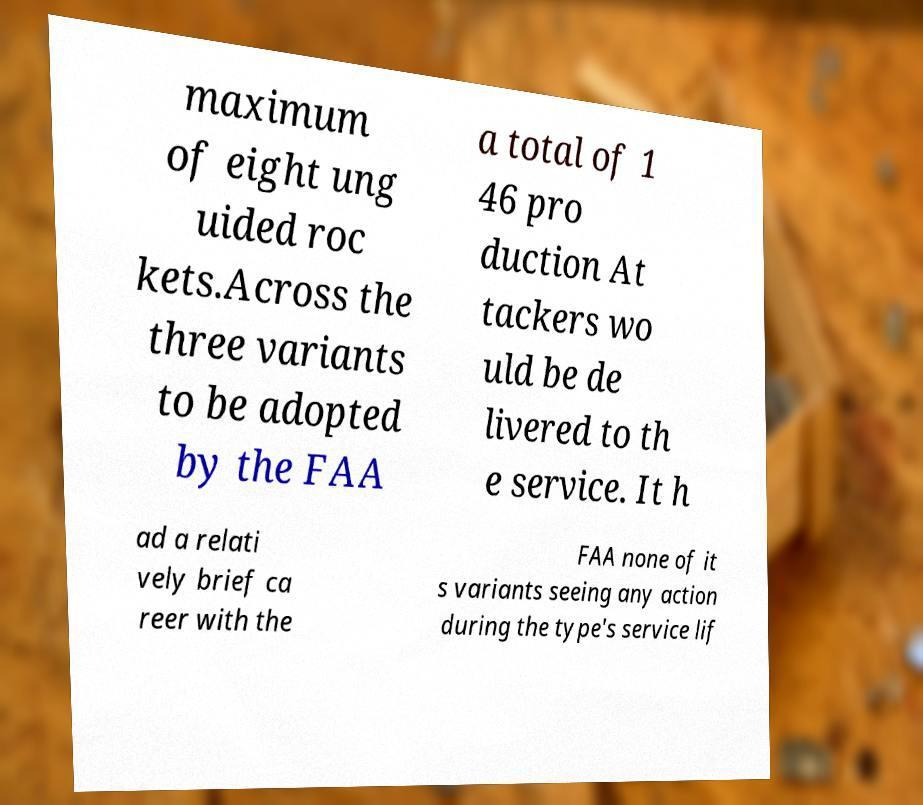Please read and relay the text visible in this image. What does it say? maximum of eight ung uided roc kets.Across the three variants to be adopted by the FAA a total of 1 46 pro duction At tackers wo uld be de livered to th e service. It h ad a relati vely brief ca reer with the FAA none of it s variants seeing any action during the type's service lif 